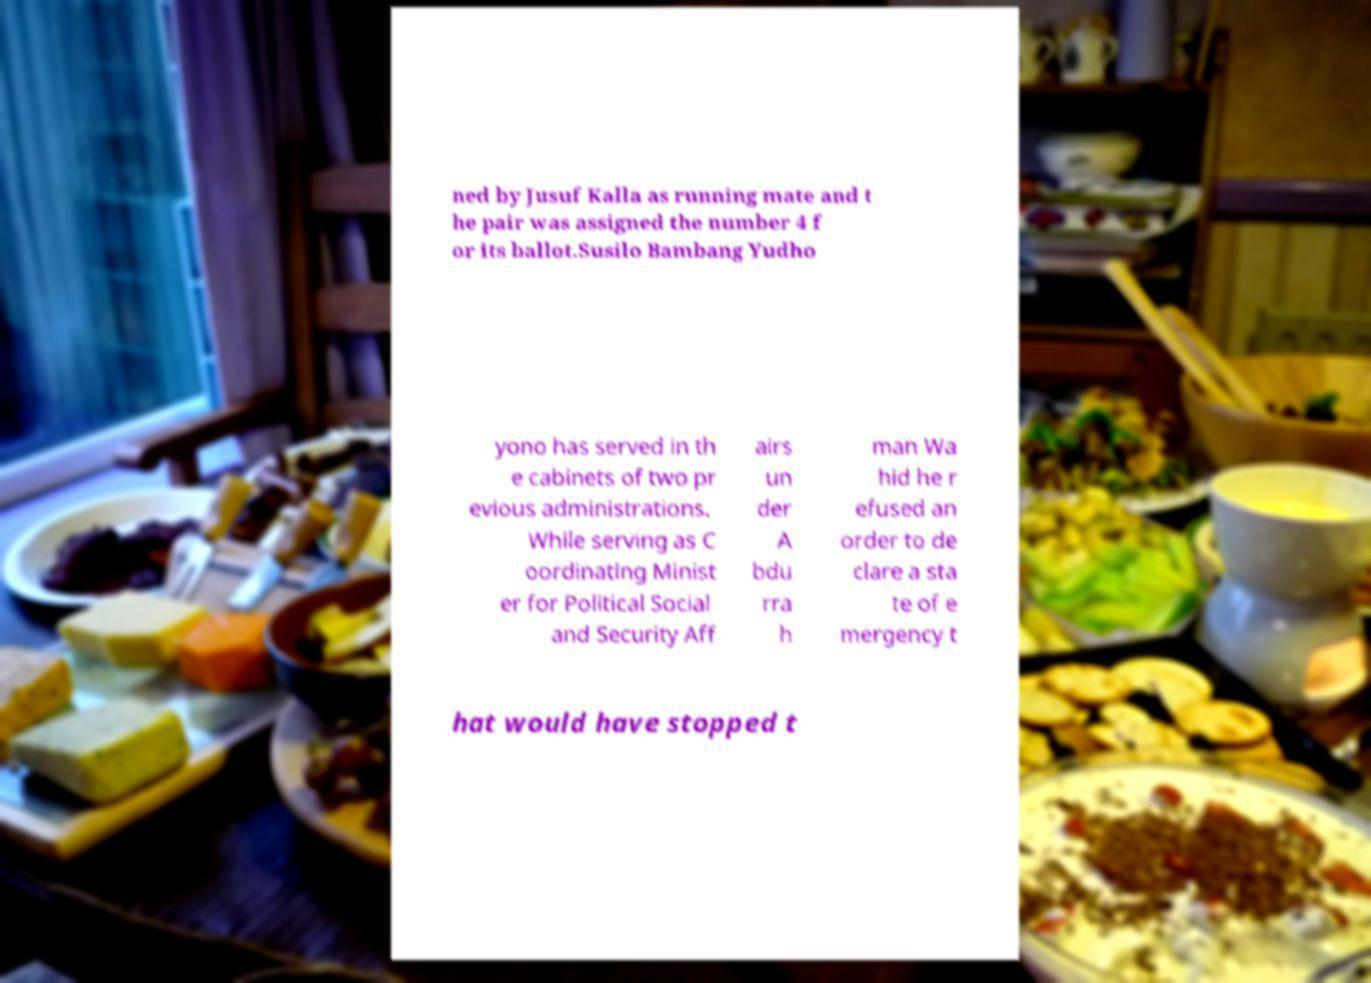For documentation purposes, I need the text within this image transcribed. Could you provide that? ned by Jusuf Kalla as running mate and t he pair was assigned the number 4 f or its ballot.Susilo Bambang Yudho yono has served in th e cabinets of two pr evious administrations. While serving as C oordinating Minist er for Political Social and Security Aff airs un der A bdu rra h man Wa hid he r efused an order to de clare a sta te of e mergency t hat would have stopped t 